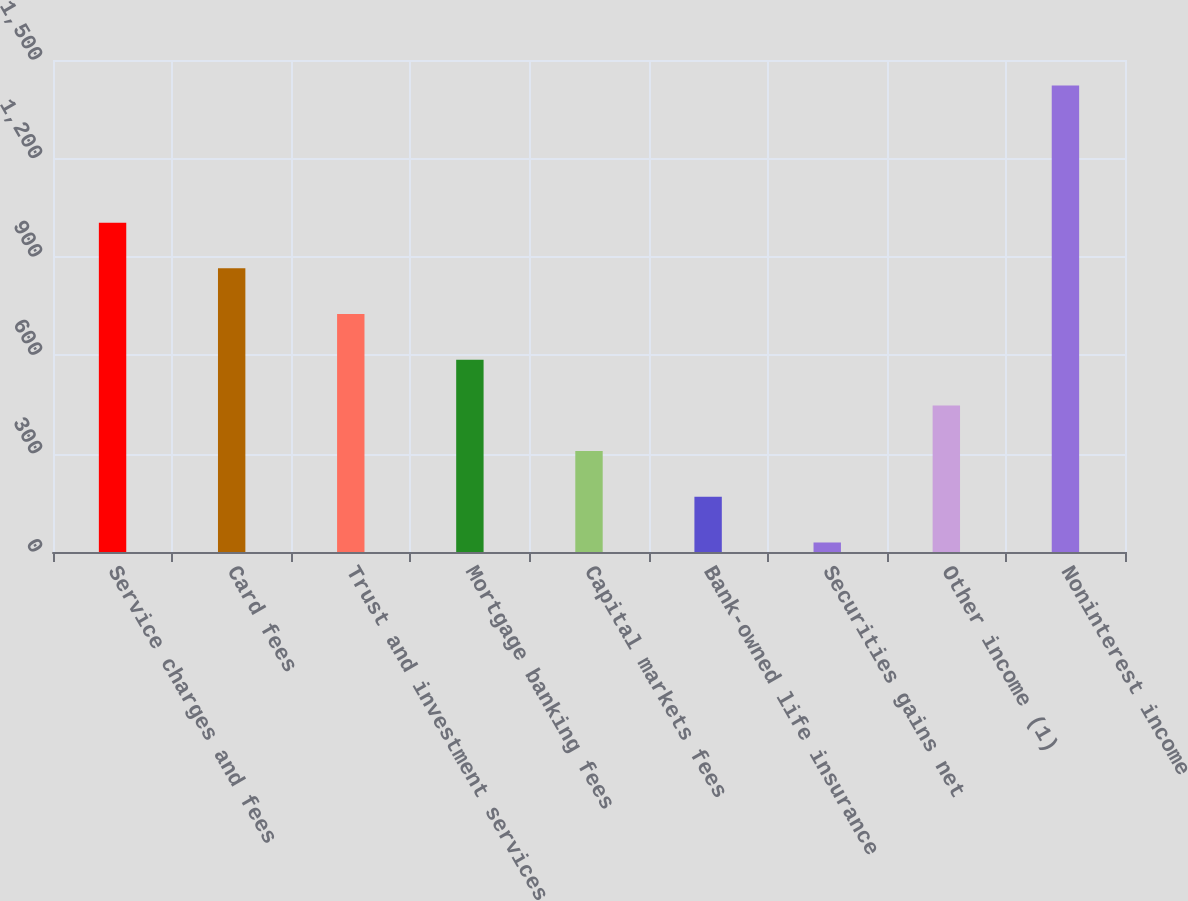<chart> <loc_0><loc_0><loc_500><loc_500><bar_chart><fcel>Service charges and fees<fcel>Card fees<fcel>Trust and investment services<fcel>Mortgage banking fees<fcel>Capital markets fees<fcel>Bank-owned life insurance<fcel>Securities gains net<fcel>Other income (1)<fcel>Noninterest income<nl><fcel>1004.1<fcel>864.8<fcel>725.5<fcel>586.2<fcel>307.6<fcel>168.3<fcel>29<fcel>446.9<fcel>1422<nl></chart> 